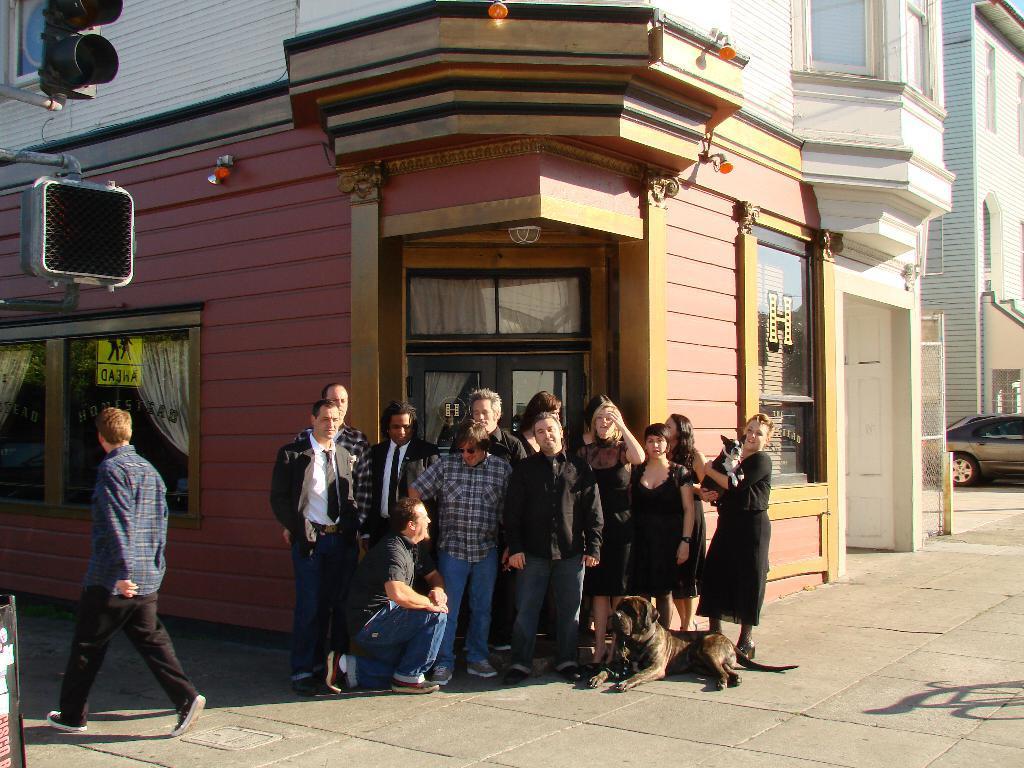Could you give a brief overview of what you see in this image? This image is clicked on the road. There are group of people standing in the center. In front of them there is a man and a dog sitting on the ground. Behind them there are buildings. To the left there is a man walking on the road. In the top left there are traffic light signals. To the right there is a car. 